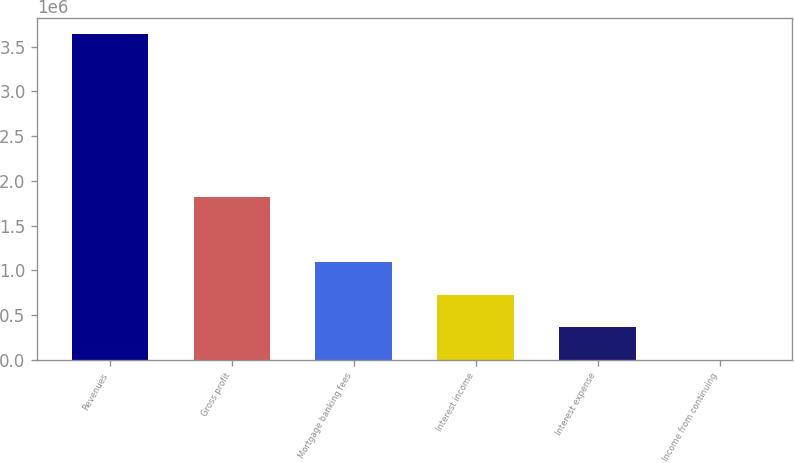Convert chart. <chart><loc_0><loc_0><loc_500><loc_500><bar_chart><fcel>Revenues<fcel>Gross profit<fcel>Mortgage banking fees<fcel>Interest income<fcel>Interest expense<fcel>Income from continuing<nl><fcel>3.6387e+06<fcel>1.81936e+06<fcel>1.09162e+06<fcel>727754<fcel>363886<fcel>17.04<nl></chart> 